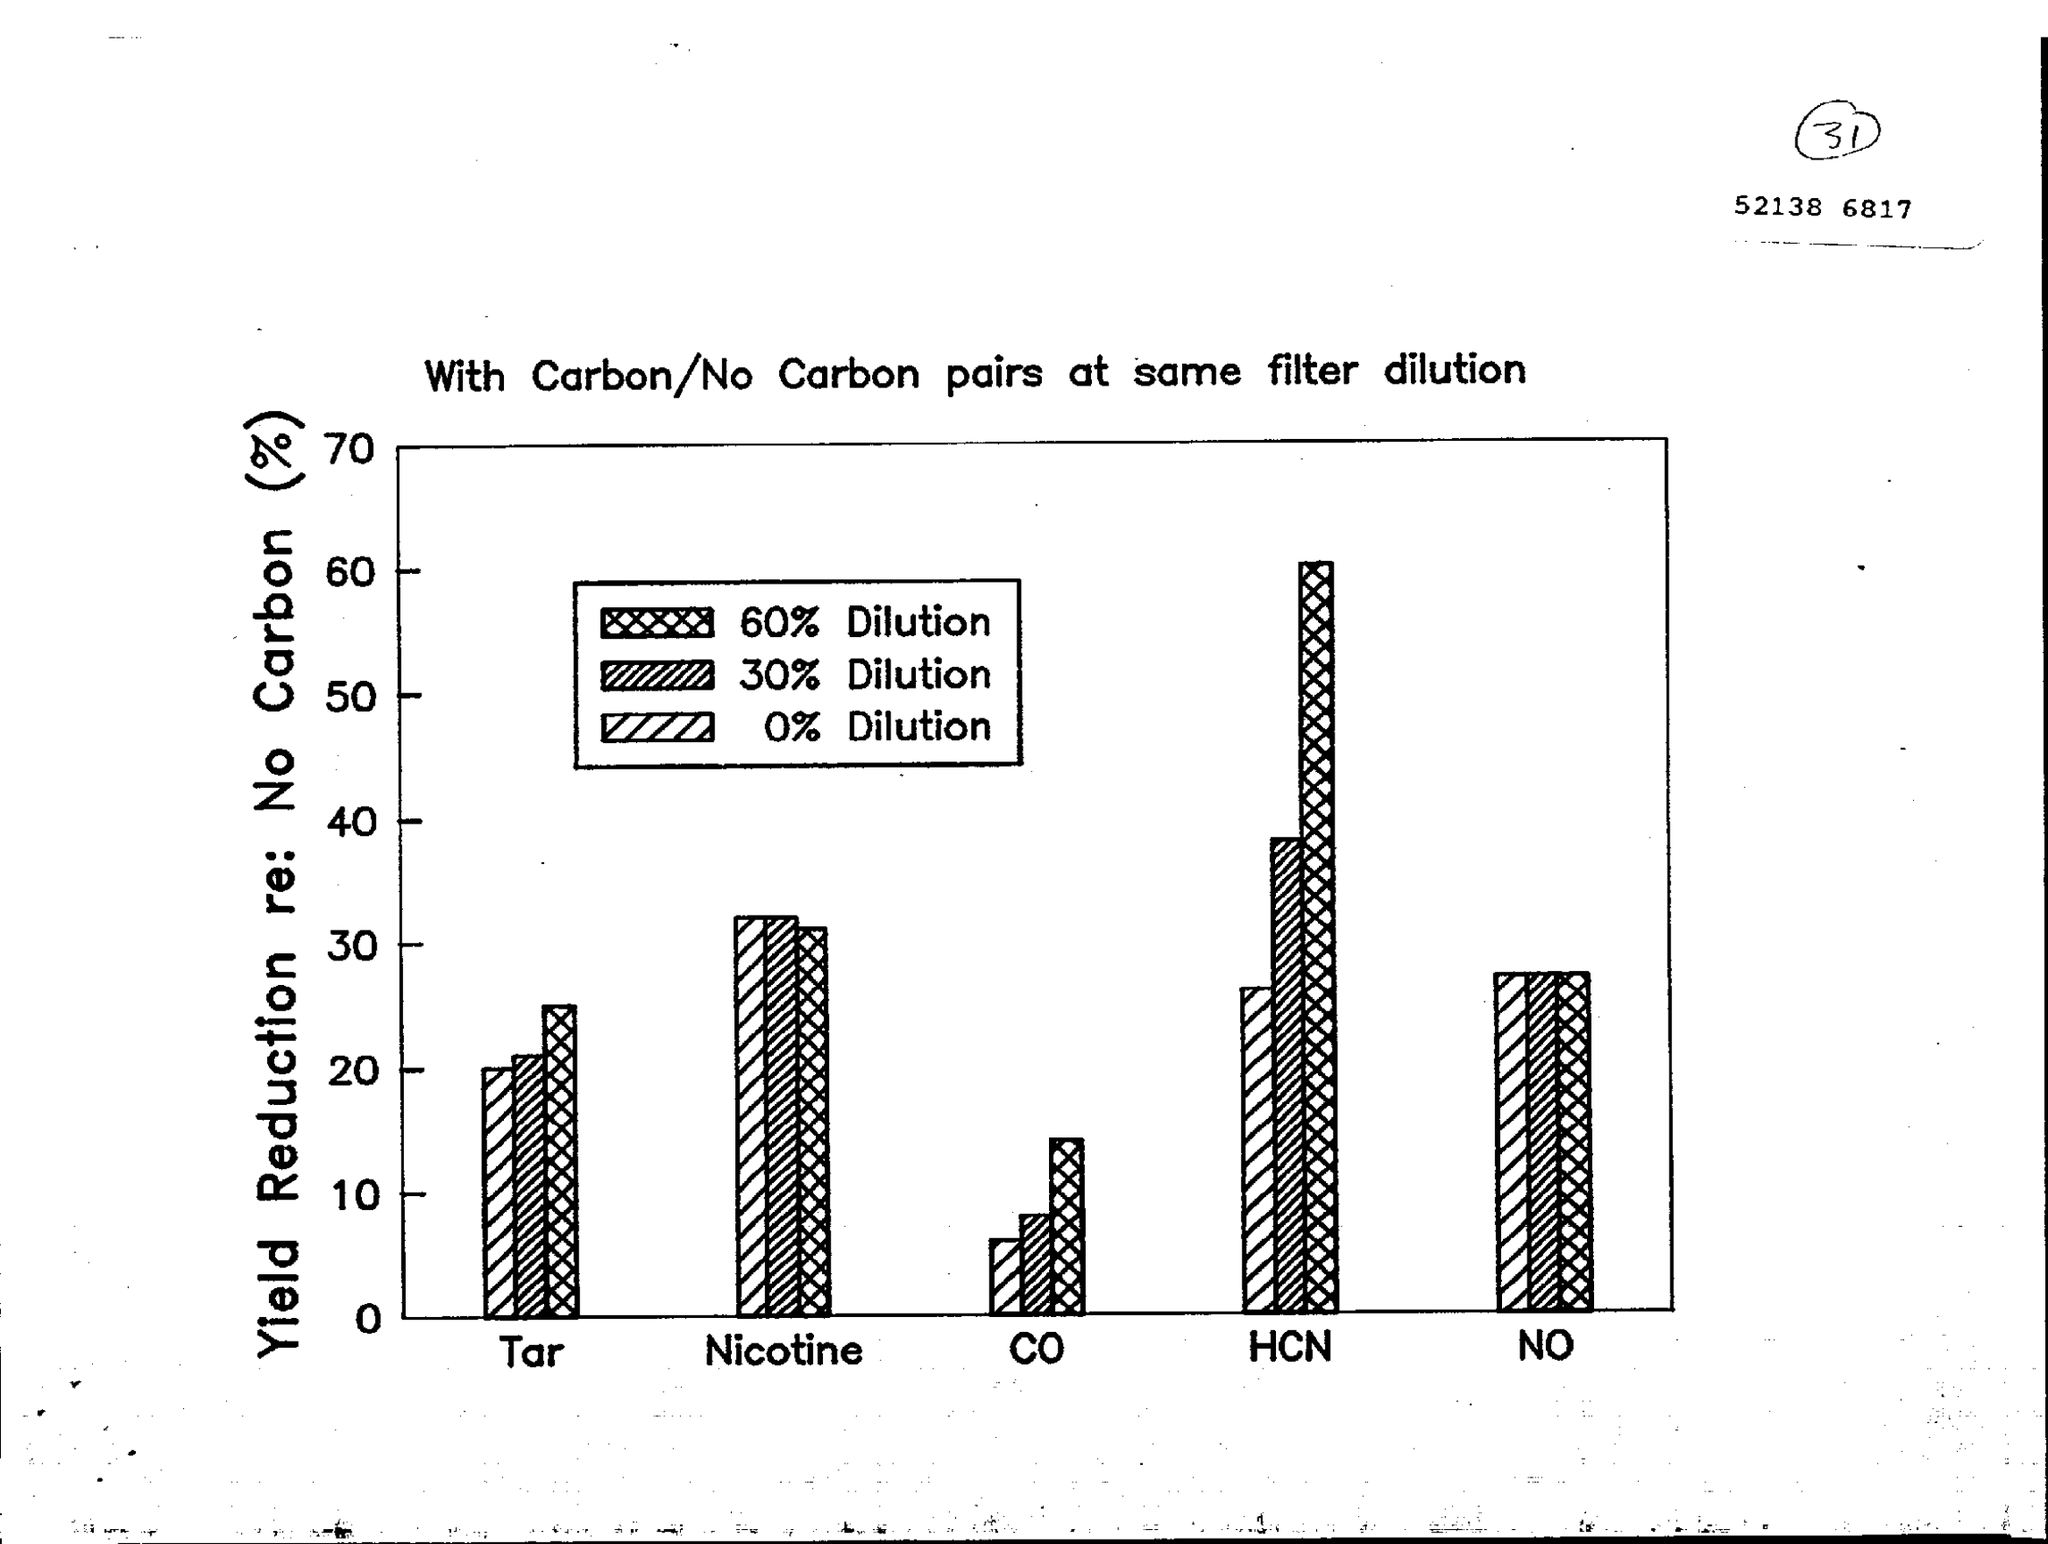Draw attention to some important aspects in this diagram. The bar chart shows the relationship between two variables, one on the y-axis and the other on the x-axis. The variable on the y-axis represents yield reduction related to the absence of carbon, expressed as a percentage. 